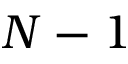Convert formula to latex. <formula><loc_0><loc_0><loc_500><loc_500>N - 1</formula> 